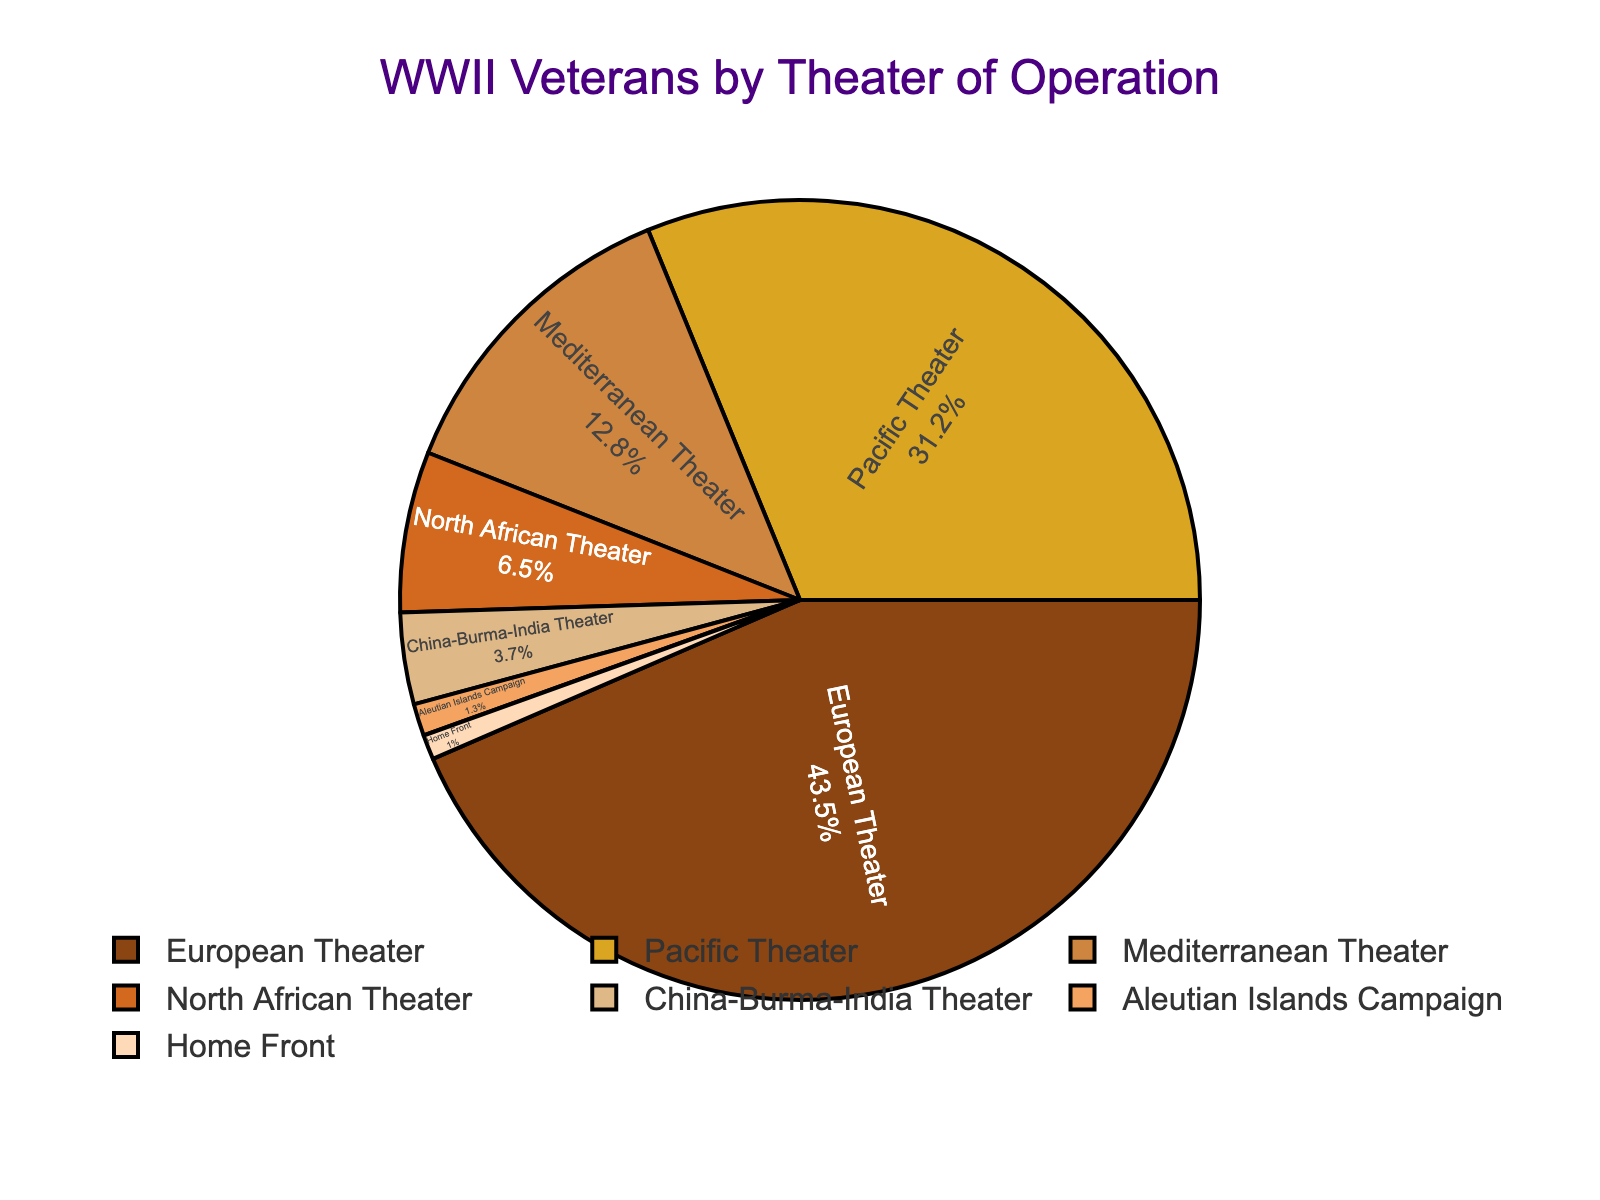Which theater of operation has the highest percentage of WWII veterans? The figure shows different theaters of operations and their respective percentages. The European Theater has the highest percentage, which is 43.5%.
Answer: European Theater Which two theaters of operation together account for more than 50% of WWII veterans? The two largest percentages are from the European Theater and the Pacific Theater. Adding them together: 43.5% (European) + 31.2% (Pacific) = 74.7%, which is more than 50%.
Answer: European Theater and Pacific Theater How much larger is the percentage of veterans in the European Theater compared to the Mediterranean Theater? The European Theater has 43.5% while the Mediterranean Theater has 12.8%. Subtracting the Mediterranean percentage from the European percentage: 43.5% - 12.8% = 30.7%.
Answer: 30.7% What is the combined percentage of veterans who served in the North African Theater and the Aleutian Islands Campaign? The percentage of veterans in the North African Theater is 6.5%, and in the Aleutian Islands Campaign, it's 1.3%. Adding these two together: 6.5% + 1.3% = 7.8%.
Answer: 7.8% Which theater of operation has the smallest percentage of WWII veterans? The figure shows different theaters and their percentages. The Home Front has the smallest percentage at 1.0%.
Answer: Home Front Is the percentage of veterans in the Pacific Theater more than double that in the Mediterranean Theater? The percentage in the Pacific Theater is 31.2% and in the Mediterranean Theater, it's 12.8%. Double the Mediterranean percentage is 12.8% * 2 = 25.6%, and 31.2% is more than 25.6%.
Answer: Yes What is the difference in the percentage of veterans between the Pacific Theater and the North African Theater? The percentage in the Pacific Theater is 31.2%, and in the North African Theater, it is 6.5%. Subtracting the North African percentage from the Pacific percentage: 31.2% - 6.5% = 24.7%.
Answer: 24.7% Are there more veterans in the China-Burma-India Theater or the Home Front? The percentage for the China-Burma-India Theater is 3.7%, while for the Home Front, it is 1.0%. 3.7% is greater than 1.0%.
Answer: China-Burma-India Theater 